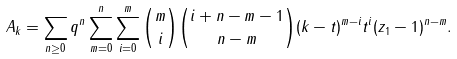<formula> <loc_0><loc_0><loc_500><loc_500>A _ { k } = \sum _ { n \geq 0 } q ^ { n } \sum _ { m = 0 } ^ { n } \sum _ { i = 0 } ^ { m } \binom { m } { i } \binom { i + n - m - 1 } { n - m } ( k - t ) ^ { m - i } t ^ { i } ( z _ { 1 } - 1 ) ^ { n - m } .</formula> 